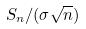<formula> <loc_0><loc_0><loc_500><loc_500>S _ { n } / ( \sigma \sqrt { n } )</formula> 